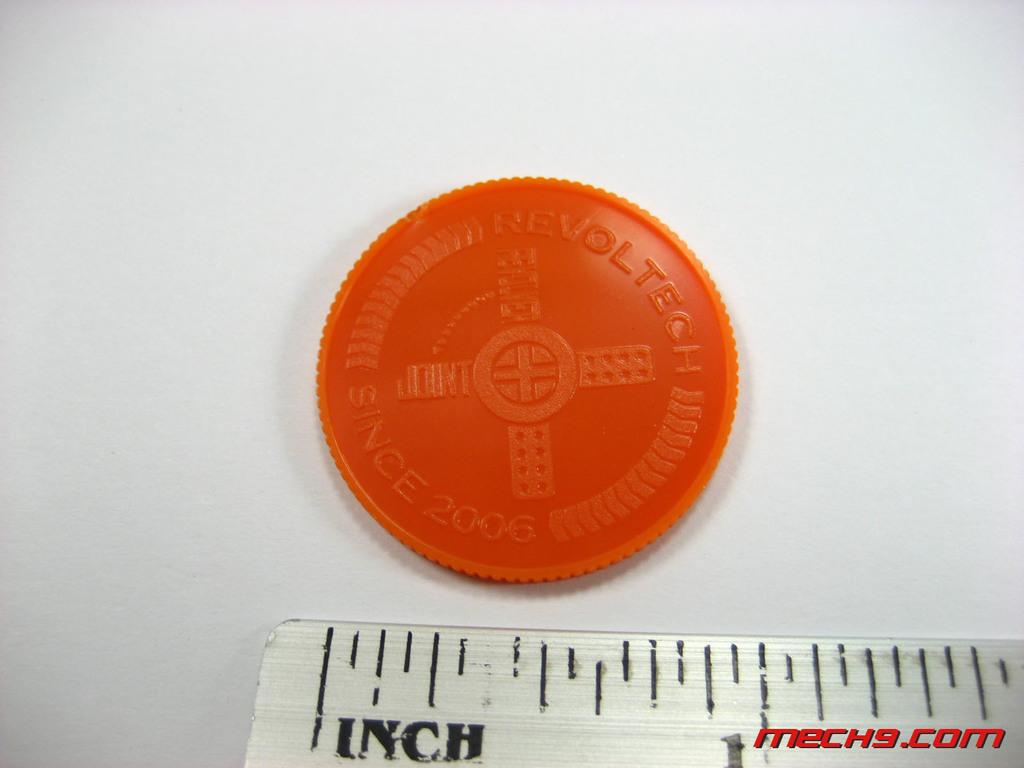What unit of measurement is this?
Your answer should be very brief. Inch. What company made the circle?
Your response must be concise. Revoltech. 